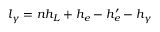Convert formula to latex. <formula><loc_0><loc_0><loc_500><loc_500>l _ { \gamma } = n h _ { L } + h _ { e } - h _ { e } ^ { \prime } - h _ { \gamma }</formula> 